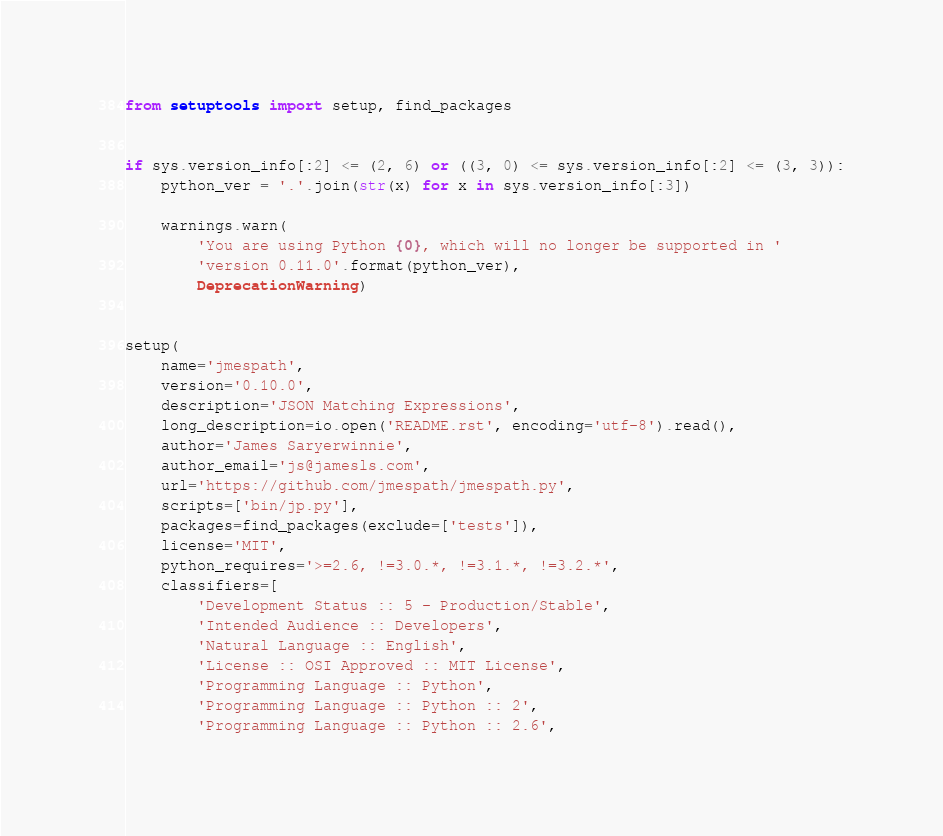<code> <loc_0><loc_0><loc_500><loc_500><_Python_>from setuptools import setup, find_packages


if sys.version_info[:2] <= (2, 6) or ((3, 0) <= sys.version_info[:2] <= (3, 3)):
    python_ver = '.'.join(str(x) for x in sys.version_info[:3])

    warnings.warn(
        'You are using Python {0}, which will no longer be supported in '
        'version 0.11.0'.format(python_ver),
        DeprecationWarning)


setup(
    name='jmespath',
    version='0.10.0',
    description='JSON Matching Expressions',
    long_description=io.open('README.rst', encoding='utf-8').read(),
    author='James Saryerwinnie',
    author_email='js@jamesls.com',
    url='https://github.com/jmespath/jmespath.py',
    scripts=['bin/jp.py'],
    packages=find_packages(exclude=['tests']),
    license='MIT',
    python_requires='>=2.6, !=3.0.*, !=3.1.*, !=3.2.*',
    classifiers=[
        'Development Status :: 5 - Production/Stable',
        'Intended Audience :: Developers',
        'Natural Language :: English',
        'License :: OSI Approved :: MIT License',
        'Programming Language :: Python',
        'Programming Language :: Python :: 2',
        'Programming Language :: Python :: 2.6',</code> 